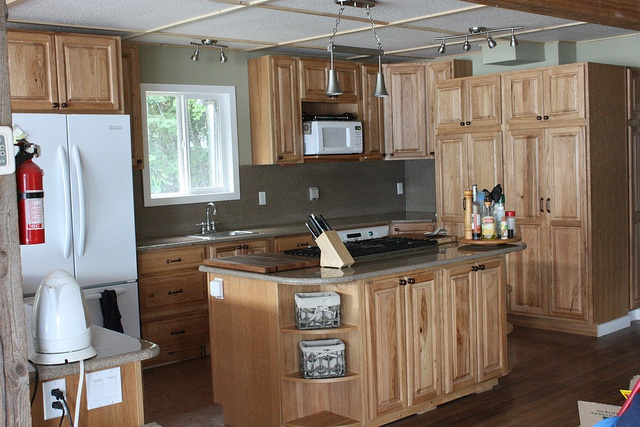Describe the objects in this image and their specific colors. I can see refrigerator in gray, lavender, lightblue, and darkgray tones, microwave in gray, darkgray, black, and lightblue tones, oven in gray, darkgray, and black tones, bottle in gray, darkgray, khaki, and lightgray tones, and bottle in gray, lightgray, darkgray, and lightpink tones in this image. 